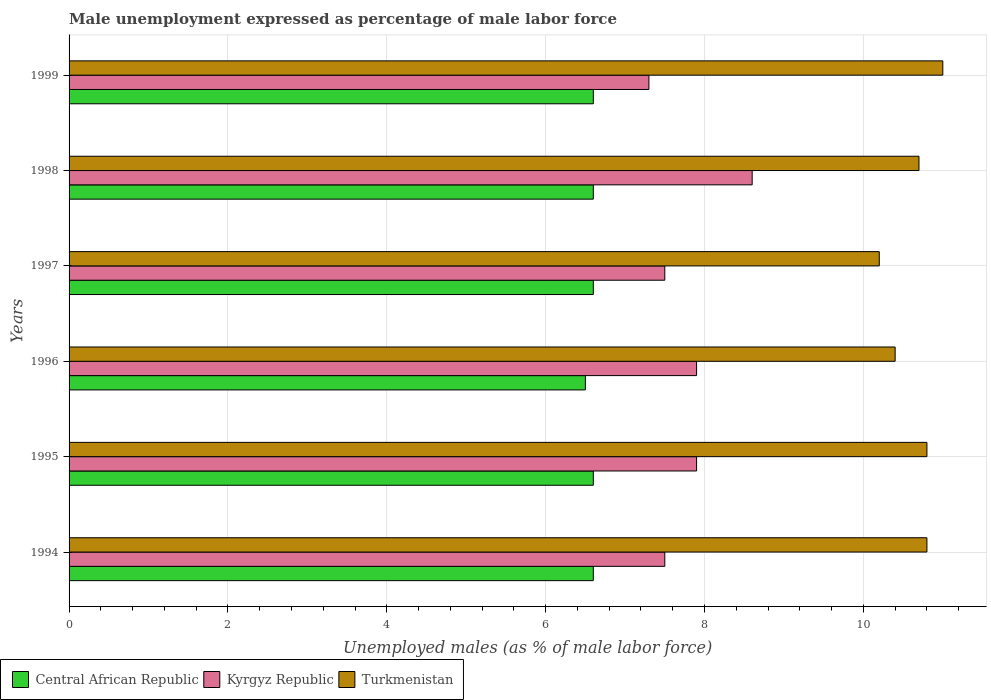How many different coloured bars are there?
Keep it short and to the point. 3. How many groups of bars are there?
Your response must be concise. 6. Are the number of bars per tick equal to the number of legend labels?
Keep it short and to the point. Yes. Are the number of bars on each tick of the Y-axis equal?
Ensure brevity in your answer.  Yes. How many bars are there on the 1st tick from the top?
Your response must be concise. 3. What is the label of the 3rd group of bars from the top?
Your answer should be very brief. 1997. What is the unemployment in males in in Central African Republic in 1996?
Your answer should be compact. 6.5. Across all years, what is the maximum unemployment in males in in Turkmenistan?
Give a very brief answer. 11. Across all years, what is the minimum unemployment in males in in Turkmenistan?
Keep it short and to the point. 10.2. What is the total unemployment in males in in Central African Republic in the graph?
Offer a very short reply. 39.5. What is the difference between the unemployment in males in in Central African Republic in 1995 and that in 1996?
Your response must be concise. 0.1. What is the difference between the unemployment in males in in Kyrgyz Republic in 1994 and the unemployment in males in in Central African Republic in 1996?
Give a very brief answer. 1. What is the average unemployment in males in in Turkmenistan per year?
Your response must be concise. 10.65. In the year 1994, what is the difference between the unemployment in males in in Kyrgyz Republic and unemployment in males in in Central African Republic?
Your answer should be compact. 0.9. What is the ratio of the unemployment in males in in Kyrgyz Republic in 1995 to that in 1997?
Your answer should be compact. 1.05. What is the difference between the highest and the second highest unemployment in males in in Turkmenistan?
Offer a terse response. 0.2. What is the difference between the highest and the lowest unemployment in males in in Kyrgyz Republic?
Your answer should be very brief. 1.3. What does the 2nd bar from the top in 1998 represents?
Make the answer very short. Kyrgyz Republic. What does the 2nd bar from the bottom in 1998 represents?
Offer a terse response. Kyrgyz Republic. How many bars are there?
Give a very brief answer. 18. Are all the bars in the graph horizontal?
Your answer should be compact. Yes. Does the graph contain any zero values?
Make the answer very short. No. Where does the legend appear in the graph?
Your answer should be very brief. Bottom left. How are the legend labels stacked?
Provide a succinct answer. Horizontal. What is the title of the graph?
Ensure brevity in your answer.  Male unemployment expressed as percentage of male labor force. What is the label or title of the X-axis?
Provide a succinct answer. Unemployed males (as % of male labor force). What is the Unemployed males (as % of male labor force) of Central African Republic in 1994?
Offer a very short reply. 6.6. What is the Unemployed males (as % of male labor force) of Turkmenistan in 1994?
Offer a terse response. 10.8. What is the Unemployed males (as % of male labor force) in Central African Republic in 1995?
Your response must be concise. 6.6. What is the Unemployed males (as % of male labor force) in Kyrgyz Republic in 1995?
Your answer should be very brief. 7.9. What is the Unemployed males (as % of male labor force) of Turkmenistan in 1995?
Provide a short and direct response. 10.8. What is the Unemployed males (as % of male labor force) of Kyrgyz Republic in 1996?
Your answer should be compact. 7.9. What is the Unemployed males (as % of male labor force) in Turkmenistan in 1996?
Offer a terse response. 10.4. What is the Unemployed males (as % of male labor force) in Central African Republic in 1997?
Your answer should be compact. 6.6. What is the Unemployed males (as % of male labor force) in Kyrgyz Republic in 1997?
Your answer should be very brief. 7.5. What is the Unemployed males (as % of male labor force) in Turkmenistan in 1997?
Ensure brevity in your answer.  10.2. What is the Unemployed males (as % of male labor force) of Central African Republic in 1998?
Offer a terse response. 6.6. What is the Unemployed males (as % of male labor force) of Kyrgyz Republic in 1998?
Provide a short and direct response. 8.6. What is the Unemployed males (as % of male labor force) of Turkmenistan in 1998?
Offer a very short reply. 10.7. What is the Unemployed males (as % of male labor force) of Central African Republic in 1999?
Offer a very short reply. 6.6. What is the Unemployed males (as % of male labor force) of Kyrgyz Republic in 1999?
Give a very brief answer. 7.3. What is the Unemployed males (as % of male labor force) in Turkmenistan in 1999?
Provide a short and direct response. 11. Across all years, what is the maximum Unemployed males (as % of male labor force) in Central African Republic?
Your answer should be compact. 6.6. Across all years, what is the maximum Unemployed males (as % of male labor force) of Kyrgyz Republic?
Provide a short and direct response. 8.6. Across all years, what is the maximum Unemployed males (as % of male labor force) of Turkmenistan?
Provide a succinct answer. 11. Across all years, what is the minimum Unemployed males (as % of male labor force) of Kyrgyz Republic?
Offer a very short reply. 7.3. Across all years, what is the minimum Unemployed males (as % of male labor force) in Turkmenistan?
Provide a succinct answer. 10.2. What is the total Unemployed males (as % of male labor force) of Central African Republic in the graph?
Provide a succinct answer. 39.5. What is the total Unemployed males (as % of male labor force) in Kyrgyz Republic in the graph?
Keep it short and to the point. 46.7. What is the total Unemployed males (as % of male labor force) in Turkmenistan in the graph?
Ensure brevity in your answer.  63.9. What is the difference between the Unemployed males (as % of male labor force) of Central African Republic in 1994 and that in 1995?
Offer a very short reply. 0. What is the difference between the Unemployed males (as % of male labor force) in Kyrgyz Republic in 1994 and that in 1995?
Offer a very short reply. -0.4. What is the difference between the Unemployed males (as % of male labor force) of Turkmenistan in 1994 and that in 1995?
Your response must be concise. 0. What is the difference between the Unemployed males (as % of male labor force) in Central African Republic in 1994 and that in 1996?
Ensure brevity in your answer.  0.1. What is the difference between the Unemployed males (as % of male labor force) of Turkmenistan in 1994 and that in 1996?
Your answer should be compact. 0.4. What is the difference between the Unemployed males (as % of male labor force) of Central African Republic in 1994 and that in 1997?
Make the answer very short. 0. What is the difference between the Unemployed males (as % of male labor force) in Central African Republic in 1994 and that in 1998?
Keep it short and to the point. 0. What is the difference between the Unemployed males (as % of male labor force) in Turkmenistan in 1994 and that in 1998?
Make the answer very short. 0.1. What is the difference between the Unemployed males (as % of male labor force) of Central African Republic in 1995 and that in 1997?
Provide a succinct answer. 0. What is the difference between the Unemployed males (as % of male labor force) in Turkmenistan in 1995 and that in 1997?
Offer a terse response. 0.6. What is the difference between the Unemployed males (as % of male labor force) of Central African Republic in 1995 and that in 1998?
Provide a short and direct response. 0. What is the difference between the Unemployed males (as % of male labor force) in Turkmenistan in 1995 and that in 1999?
Keep it short and to the point. -0.2. What is the difference between the Unemployed males (as % of male labor force) of Central African Republic in 1996 and that in 1998?
Provide a succinct answer. -0.1. What is the difference between the Unemployed males (as % of male labor force) in Kyrgyz Republic in 1996 and that in 1998?
Keep it short and to the point. -0.7. What is the difference between the Unemployed males (as % of male labor force) in Turkmenistan in 1996 and that in 1998?
Provide a succinct answer. -0.3. What is the difference between the Unemployed males (as % of male labor force) of Turkmenistan in 1996 and that in 1999?
Your answer should be compact. -0.6. What is the difference between the Unemployed males (as % of male labor force) of Central African Republic in 1997 and that in 1998?
Keep it short and to the point. 0. What is the difference between the Unemployed males (as % of male labor force) of Kyrgyz Republic in 1997 and that in 1999?
Keep it short and to the point. 0.2. What is the difference between the Unemployed males (as % of male labor force) in Turkmenistan in 1997 and that in 1999?
Provide a succinct answer. -0.8. What is the difference between the Unemployed males (as % of male labor force) in Central African Republic in 1998 and that in 1999?
Make the answer very short. 0. What is the difference between the Unemployed males (as % of male labor force) of Kyrgyz Republic in 1998 and that in 1999?
Offer a very short reply. 1.3. What is the difference between the Unemployed males (as % of male labor force) in Central African Republic in 1994 and the Unemployed males (as % of male labor force) in Kyrgyz Republic in 1995?
Keep it short and to the point. -1.3. What is the difference between the Unemployed males (as % of male labor force) in Central African Republic in 1994 and the Unemployed males (as % of male labor force) in Turkmenistan in 1995?
Provide a short and direct response. -4.2. What is the difference between the Unemployed males (as % of male labor force) in Kyrgyz Republic in 1994 and the Unemployed males (as % of male labor force) in Turkmenistan in 1997?
Provide a succinct answer. -2.7. What is the difference between the Unemployed males (as % of male labor force) of Central African Republic in 1994 and the Unemployed males (as % of male labor force) of Turkmenistan in 1998?
Provide a succinct answer. -4.1. What is the difference between the Unemployed males (as % of male labor force) in Kyrgyz Republic in 1994 and the Unemployed males (as % of male labor force) in Turkmenistan in 1998?
Offer a terse response. -3.2. What is the difference between the Unemployed males (as % of male labor force) of Central African Republic in 1994 and the Unemployed males (as % of male labor force) of Turkmenistan in 1999?
Offer a terse response. -4.4. What is the difference between the Unemployed males (as % of male labor force) of Kyrgyz Republic in 1995 and the Unemployed males (as % of male labor force) of Turkmenistan in 1996?
Make the answer very short. -2.5. What is the difference between the Unemployed males (as % of male labor force) of Central African Republic in 1995 and the Unemployed males (as % of male labor force) of Kyrgyz Republic in 1997?
Provide a short and direct response. -0.9. What is the difference between the Unemployed males (as % of male labor force) of Kyrgyz Republic in 1995 and the Unemployed males (as % of male labor force) of Turkmenistan in 1997?
Your answer should be compact. -2.3. What is the difference between the Unemployed males (as % of male labor force) in Central African Republic in 1995 and the Unemployed males (as % of male labor force) in Turkmenistan in 1998?
Your answer should be compact. -4.1. What is the difference between the Unemployed males (as % of male labor force) of Kyrgyz Republic in 1995 and the Unemployed males (as % of male labor force) of Turkmenistan in 1998?
Offer a very short reply. -2.8. What is the difference between the Unemployed males (as % of male labor force) in Central African Republic in 1995 and the Unemployed males (as % of male labor force) in Kyrgyz Republic in 1999?
Your answer should be compact. -0.7. What is the difference between the Unemployed males (as % of male labor force) of Central African Republic in 1995 and the Unemployed males (as % of male labor force) of Turkmenistan in 1999?
Ensure brevity in your answer.  -4.4. What is the difference between the Unemployed males (as % of male labor force) in Central African Republic in 1996 and the Unemployed males (as % of male labor force) in Kyrgyz Republic in 1997?
Provide a succinct answer. -1. What is the difference between the Unemployed males (as % of male labor force) of Central African Republic in 1996 and the Unemployed males (as % of male labor force) of Kyrgyz Republic in 1998?
Provide a succinct answer. -2.1. What is the difference between the Unemployed males (as % of male labor force) of Kyrgyz Republic in 1996 and the Unemployed males (as % of male labor force) of Turkmenistan in 1998?
Provide a short and direct response. -2.8. What is the difference between the Unemployed males (as % of male labor force) in Central African Republic in 1996 and the Unemployed males (as % of male labor force) in Kyrgyz Republic in 1999?
Provide a succinct answer. -0.8. What is the difference between the Unemployed males (as % of male labor force) of Central African Republic in 1997 and the Unemployed males (as % of male labor force) of Turkmenistan in 1999?
Ensure brevity in your answer.  -4.4. What is the difference between the Unemployed males (as % of male labor force) of Kyrgyz Republic in 1997 and the Unemployed males (as % of male labor force) of Turkmenistan in 1999?
Your answer should be compact. -3.5. What is the difference between the Unemployed males (as % of male labor force) in Central African Republic in 1998 and the Unemployed males (as % of male labor force) in Kyrgyz Republic in 1999?
Keep it short and to the point. -0.7. What is the average Unemployed males (as % of male labor force) in Central African Republic per year?
Provide a short and direct response. 6.58. What is the average Unemployed males (as % of male labor force) of Kyrgyz Republic per year?
Ensure brevity in your answer.  7.78. What is the average Unemployed males (as % of male labor force) of Turkmenistan per year?
Keep it short and to the point. 10.65. In the year 1994, what is the difference between the Unemployed males (as % of male labor force) in Central African Republic and Unemployed males (as % of male labor force) in Kyrgyz Republic?
Your answer should be very brief. -0.9. In the year 1994, what is the difference between the Unemployed males (as % of male labor force) in Central African Republic and Unemployed males (as % of male labor force) in Turkmenistan?
Give a very brief answer. -4.2. In the year 1995, what is the difference between the Unemployed males (as % of male labor force) of Central African Republic and Unemployed males (as % of male labor force) of Kyrgyz Republic?
Offer a very short reply. -1.3. In the year 1995, what is the difference between the Unemployed males (as % of male labor force) of Kyrgyz Republic and Unemployed males (as % of male labor force) of Turkmenistan?
Make the answer very short. -2.9. In the year 1996, what is the difference between the Unemployed males (as % of male labor force) of Central African Republic and Unemployed males (as % of male labor force) of Kyrgyz Republic?
Offer a terse response. -1.4. In the year 1997, what is the difference between the Unemployed males (as % of male labor force) of Central African Republic and Unemployed males (as % of male labor force) of Kyrgyz Republic?
Make the answer very short. -0.9. In the year 1997, what is the difference between the Unemployed males (as % of male labor force) in Central African Republic and Unemployed males (as % of male labor force) in Turkmenistan?
Your answer should be compact. -3.6. In the year 1998, what is the difference between the Unemployed males (as % of male labor force) of Central African Republic and Unemployed males (as % of male labor force) of Turkmenistan?
Your response must be concise. -4.1. In the year 1999, what is the difference between the Unemployed males (as % of male labor force) in Central African Republic and Unemployed males (as % of male labor force) in Kyrgyz Republic?
Ensure brevity in your answer.  -0.7. In the year 1999, what is the difference between the Unemployed males (as % of male labor force) in Central African Republic and Unemployed males (as % of male labor force) in Turkmenistan?
Your answer should be very brief. -4.4. What is the ratio of the Unemployed males (as % of male labor force) in Central African Republic in 1994 to that in 1995?
Your response must be concise. 1. What is the ratio of the Unemployed males (as % of male labor force) in Kyrgyz Republic in 1994 to that in 1995?
Your answer should be compact. 0.95. What is the ratio of the Unemployed males (as % of male labor force) in Central African Republic in 1994 to that in 1996?
Keep it short and to the point. 1.02. What is the ratio of the Unemployed males (as % of male labor force) in Kyrgyz Republic in 1994 to that in 1996?
Provide a succinct answer. 0.95. What is the ratio of the Unemployed males (as % of male labor force) in Turkmenistan in 1994 to that in 1996?
Ensure brevity in your answer.  1.04. What is the ratio of the Unemployed males (as % of male labor force) of Turkmenistan in 1994 to that in 1997?
Your answer should be very brief. 1.06. What is the ratio of the Unemployed males (as % of male labor force) in Kyrgyz Republic in 1994 to that in 1998?
Ensure brevity in your answer.  0.87. What is the ratio of the Unemployed males (as % of male labor force) in Turkmenistan in 1994 to that in 1998?
Ensure brevity in your answer.  1.01. What is the ratio of the Unemployed males (as % of male labor force) in Central African Republic in 1994 to that in 1999?
Make the answer very short. 1. What is the ratio of the Unemployed males (as % of male labor force) of Kyrgyz Republic in 1994 to that in 1999?
Provide a short and direct response. 1.03. What is the ratio of the Unemployed males (as % of male labor force) in Turkmenistan in 1994 to that in 1999?
Offer a terse response. 0.98. What is the ratio of the Unemployed males (as % of male labor force) of Central African Republic in 1995 to that in 1996?
Keep it short and to the point. 1.02. What is the ratio of the Unemployed males (as % of male labor force) in Kyrgyz Republic in 1995 to that in 1996?
Give a very brief answer. 1. What is the ratio of the Unemployed males (as % of male labor force) of Turkmenistan in 1995 to that in 1996?
Offer a very short reply. 1.04. What is the ratio of the Unemployed males (as % of male labor force) of Kyrgyz Republic in 1995 to that in 1997?
Make the answer very short. 1.05. What is the ratio of the Unemployed males (as % of male labor force) of Turkmenistan in 1995 to that in 1997?
Offer a very short reply. 1.06. What is the ratio of the Unemployed males (as % of male labor force) in Central African Republic in 1995 to that in 1998?
Provide a short and direct response. 1. What is the ratio of the Unemployed males (as % of male labor force) of Kyrgyz Republic in 1995 to that in 1998?
Provide a succinct answer. 0.92. What is the ratio of the Unemployed males (as % of male labor force) in Turkmenistan in 1995 to that in 1998?
Ensure brevity in your answer.  1.01. What is the ratio of the Unemployed males (as % of male labor force) in Kyrgyz Republic in 1995 to that in 1999?
Give a very brief answer. 1.08. What is the ratio of the Unemployed males (as % of male labor force) in Turkmenistan in 1995 to that in 1999?
Your answer should be compact. 0.98. What is the ratio of the Unemployed males (as % of male labor force) in Kyrgyz Republic in 1996 to that in 1997?
Offer a terse response. 1.05. What is the ratio of the Unemployed males (as % of male labor force) of Turkmenistan in 1996 to that in 1997?
Offer a terse response. 1.02. What is the ratio of the Unemployed males (as % of male labor force) of Central African Republic in 1996 to that in 1998?
Offer a terse response. 0.98. What is the ratio of the Unemployed males (as % of male labor force) of Kyrgyz Republic in 1996 to that in 1998?
Provide a succinct answer. 0.92. What is the ratio of the Unemployed males (as % of male labor force) of Turkmenistan in 1996 to that in 1998?
Give a very brief answer. 0.97. What is the ratio of the Unemployed males (as % of male labor force) of Central African Republic in 1996 to that in 1999?
Your answer should be compact. 0.98. What is the ratio of the Unemployed males (as % of male labor force) in Kyrgyz Republic in 1996 to that in 1999?
Keep it short and to the point. 1.08. What is the ratio of the Unemployed males (as % of male labor force) in Turkmenistan in 1996 to that in 1999?
Offer a very short reply. 0.95. What is the ratio of the Unemployed males (as % of male labor force) in Kyrgyz Republic in 1997 to that in 1998?
Your answer should be compact. 0.87. What is the ratio of the Unemployed males (as % of male labor force) of Turkmenistan in 1997 to that in 1998?
Offer a very short reply. 0.95. What is the ratio of the Unemployed males (as % of male labor force) of Kyrgyz Republic in 1997 to that in 1999?
Keep it short and to the point. 1.03. What is the ratio of the Unemployed males (as % of male labor force) of Turkmenistan in 1997 to that in 1999?
Your answer should be very brief. 0.93. What is the ratio of the Unemployed males (as % of male labor force) in Central African Republic in 1998 to that in 1999?
Offer a very short reply. 1. What is the ratio of the Unemployed males (as % of male labor force) of Kyrgyz Republic in 1998 to that in 1999?
Your answer should be compact. 1.18. What is the ratio of the Unemployed males (as % of male labor force) of Turkmenistan in 1998 to that in 1999?
Your answer should be very brief. 0.97. 